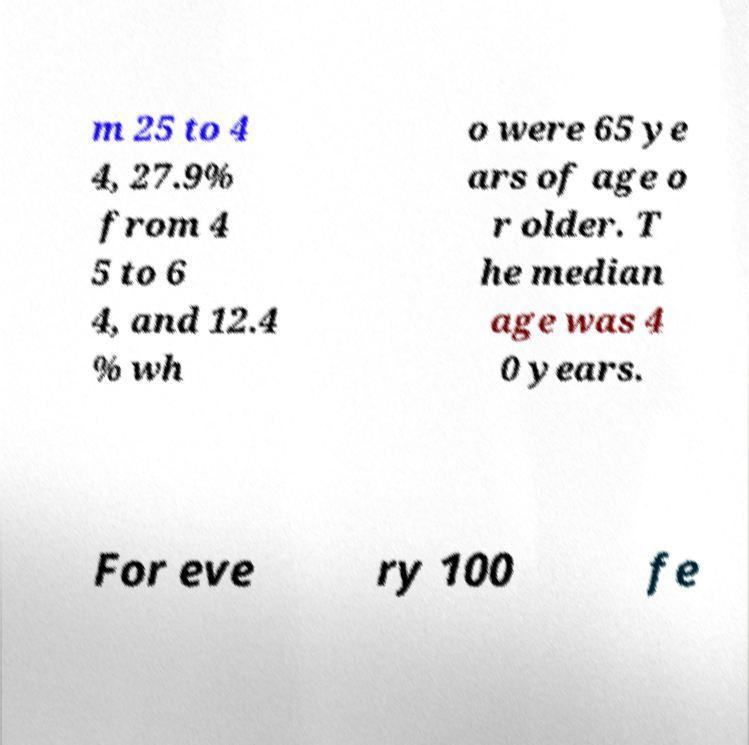Please read and relay the text visible in this image. What does it say? m 25 to 4 4, 27.9% from 4 5 to 6 4, and 12.4 % wh o were 65 ye ars of age o r older. T he median age was 4 0 years. For eve ry 100 fe 